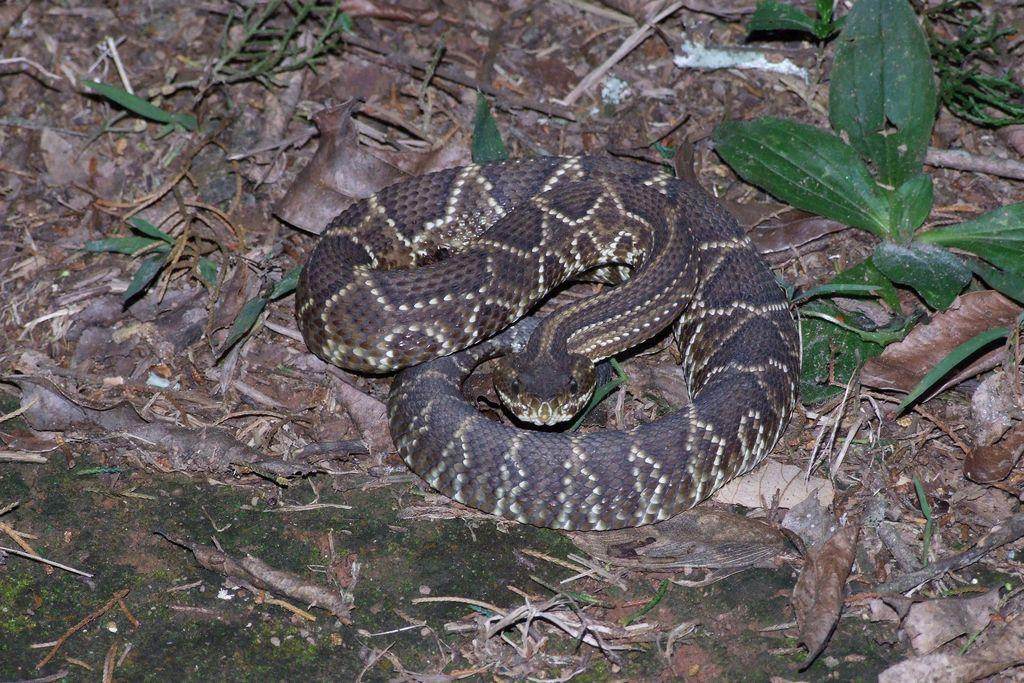What animal is present in the image? There is a snake in the image. Where is the snake located? The snake is on the ground. What type of vegetation can be seen in the image? There is grass visible in the image. How many houses can be seen in the image? There are no houses present in the image; it features a snake on the ground with grass visible. 